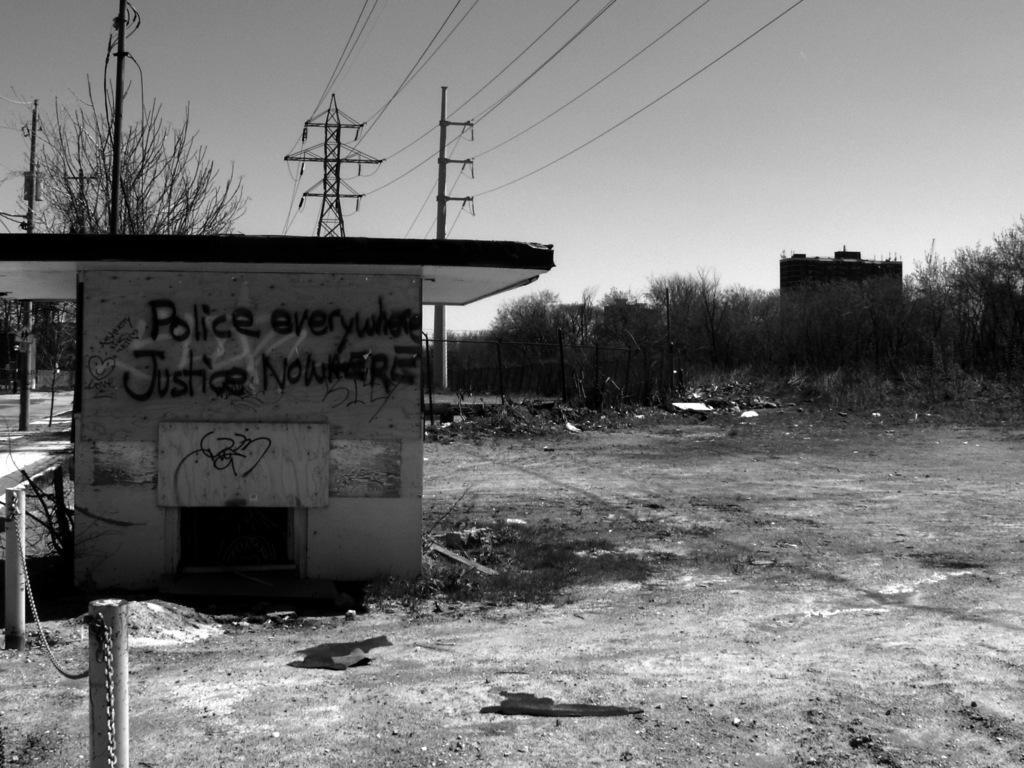Can you describe this image briefly? In this picture we can see buildings, poles, wires, trees, fence and in the background we can see the sky. 